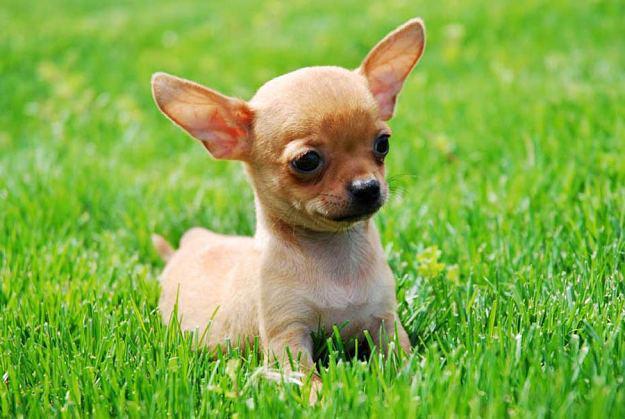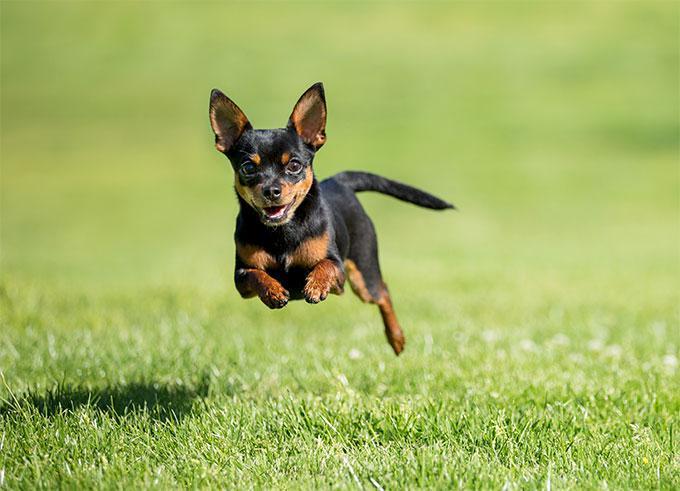The first image is the image on the left, the second image is the image on the right. Given the left and right images, does the statement "A dog in one image is photographed while in mid-air." hold true? Answer yes or no. Yes. 